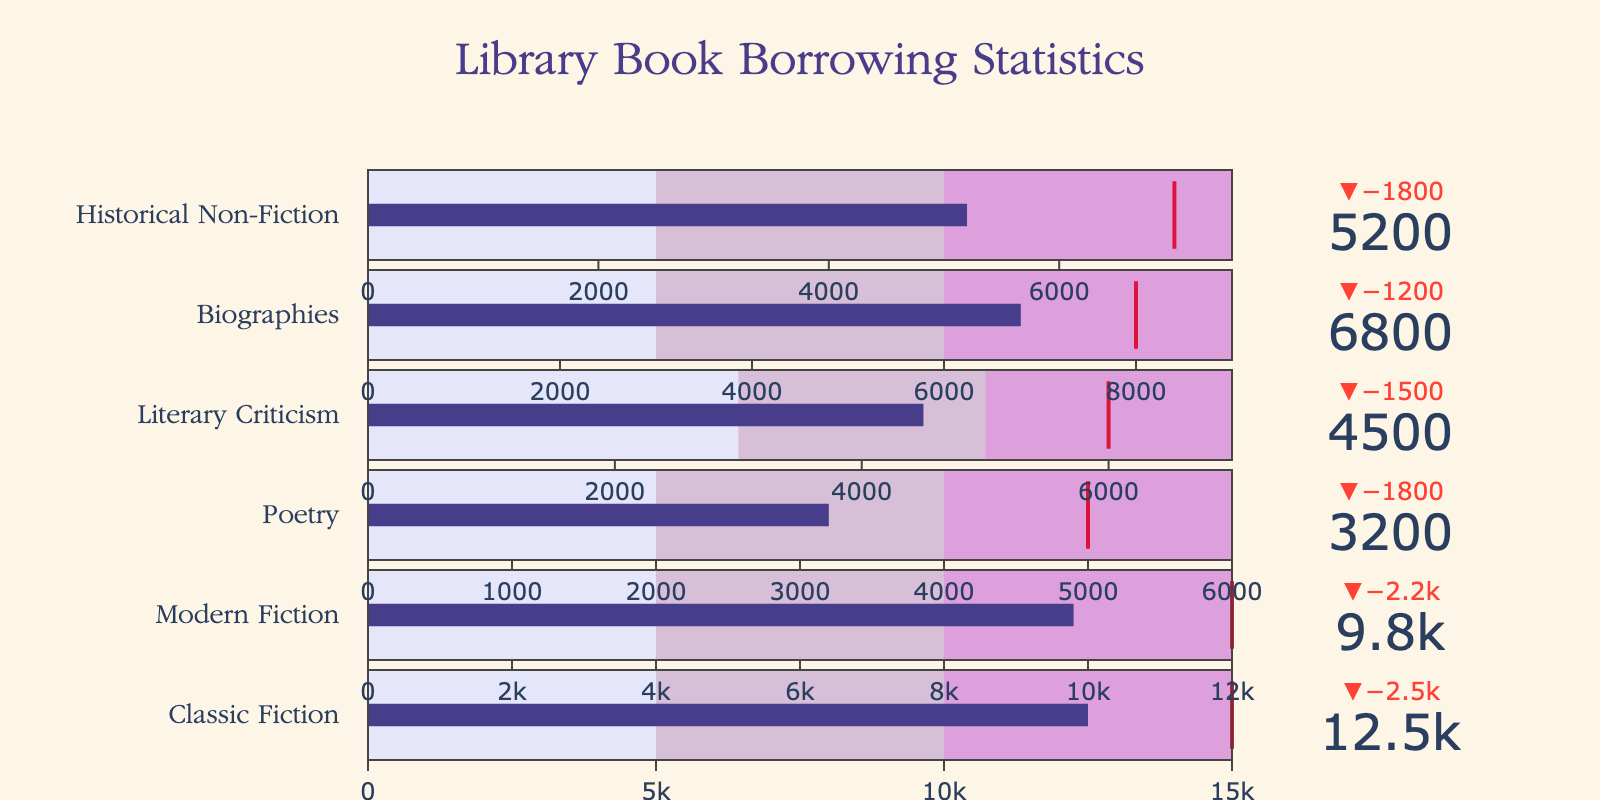How many categories are represented in the chart? The chart depicts separate sections for each category or type of book borrowing statistic. By counting these sections, we can determine the number of categories.
Answer: 6 What is the title of the chart? The title is usually positioned at the top center of the chart, written in a larger and more distinct font compared to other text elements.
Answer: Library Book Borrowing Statistics Which category has the highest actual borrowing value? By looking at each category's actual borrowing value (the number prominently displayed on the bullet chart for each section), we identify the highest value.
Answer: Classic Fiction What are the color gradients used in the chart's gauge bars? Each bullet chart uses different shading to represent different ranges. By observing the legend, we can identify the colors used.
Answer: Lavender, Thistle, Plum, Dark Slate Blue, and Crimson Has the Biographies category met its target borrowing value? To determine this, we compare the 'Actual' and 'Target' values for the Biographies section. If 'Actual' is equal to or greater than 'Target,' the target is met.
Answer: No What is the difference between the target and actual borrowings for Modern Fiction? Subtract the actual borrowing value from the target borrowing value for Modern Fiction.
Answer: 2200 Which category has the smallest difference between the target and the actual borrowing values? For each category, compute the difference between the target and actual values, then identify the smallest difference.
Answer: Historical Non-Fiction How does the actual borrowing of Literary Criticism compare to that of Poetry? Compare 'Actual' values of Literary Criticism and Poetry to determine which is higher.
Answer: Literary Criticism is higher What is the total actual borrowing for all non-fiction categories combined? Add the actual borrowing values for Biographies and Historical Non-Fiction, as these are the non-fiction categories.
Answer: 12000 What proportion of the Classic Fiction target was met? Divide the actual borrowing value of Classic Fiction by its target value and multiply by 100 to get the percentage.
Answer: 83.33% 